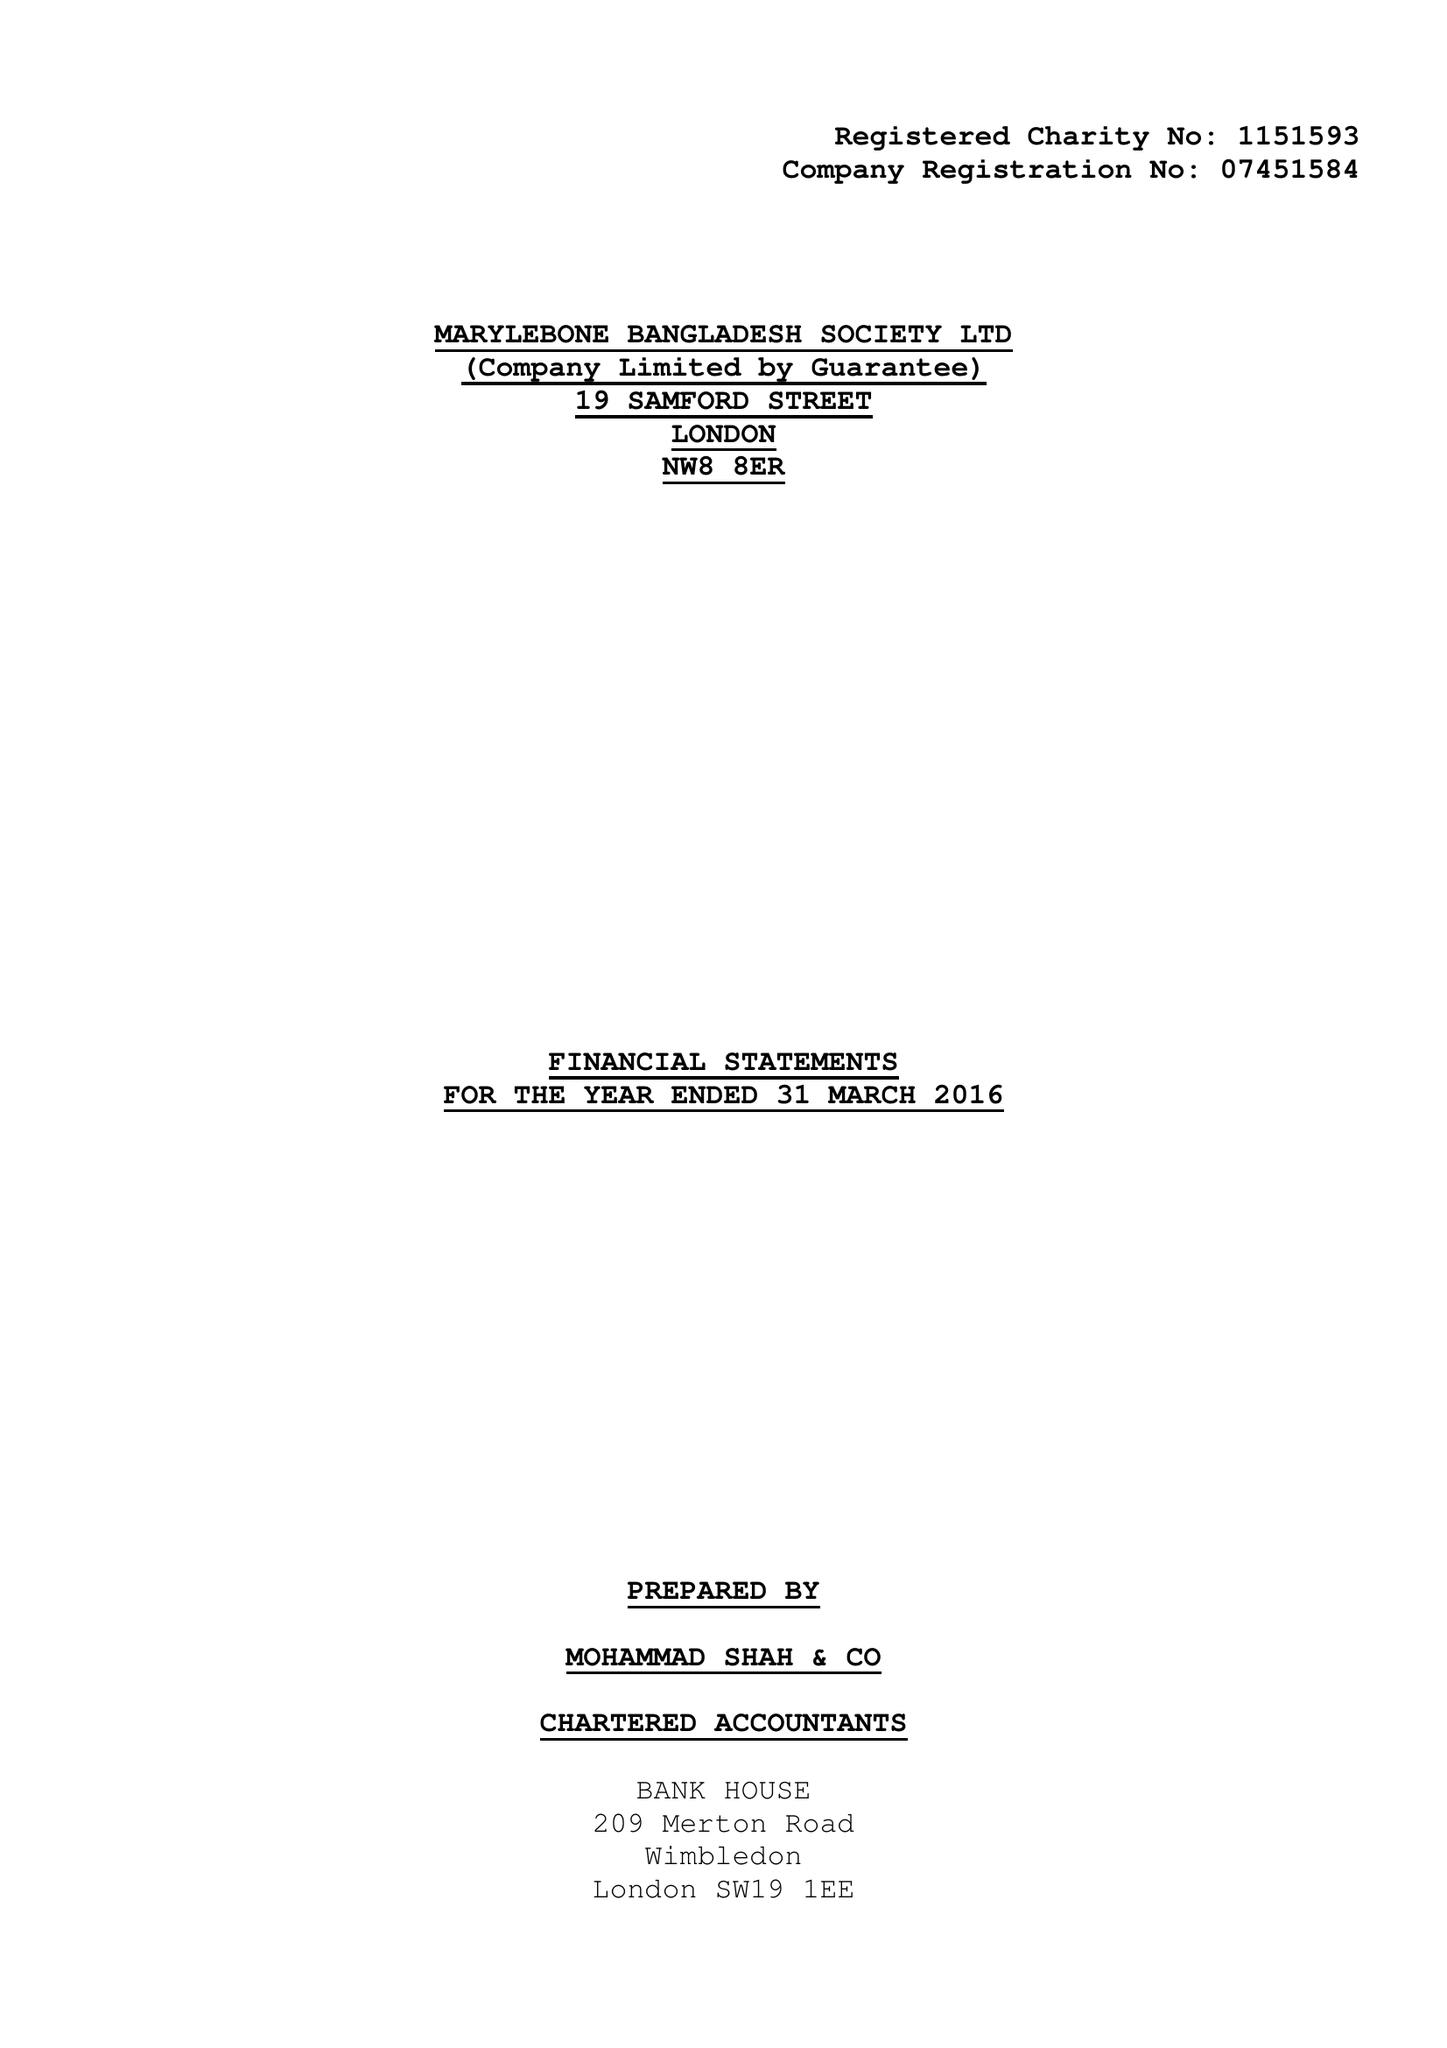What is the value for the charity_number?
Answer the question using a single word or phrase. 1151593 